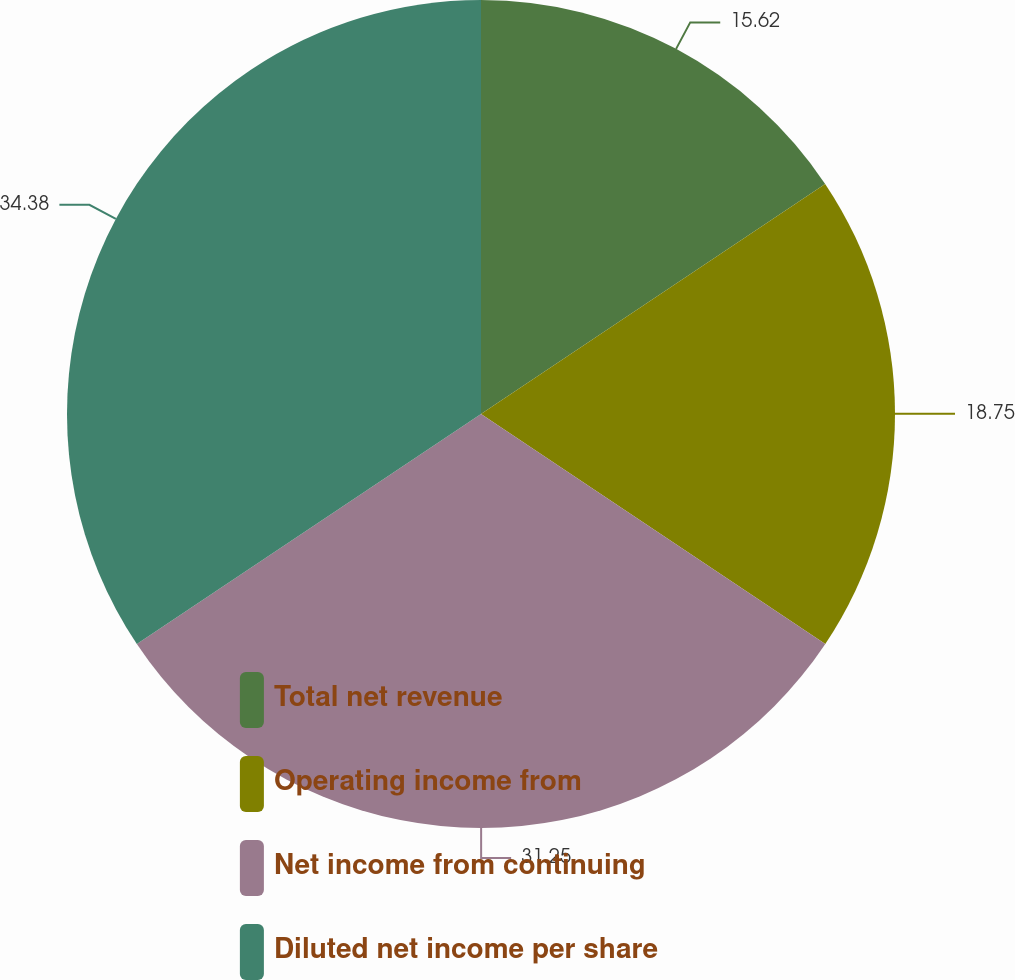<chart> <loc_0><loc_0><loc_500><loc_500><pie_chart><fcel>Total net revenue<fcel>Operating income from<fcel>Net income from continuing<fcel>Diluted net income per share<nl><fcel>15.62%<fcel>18.75%<fcel>31.25%<fcel>34.38%<nl></chart> 